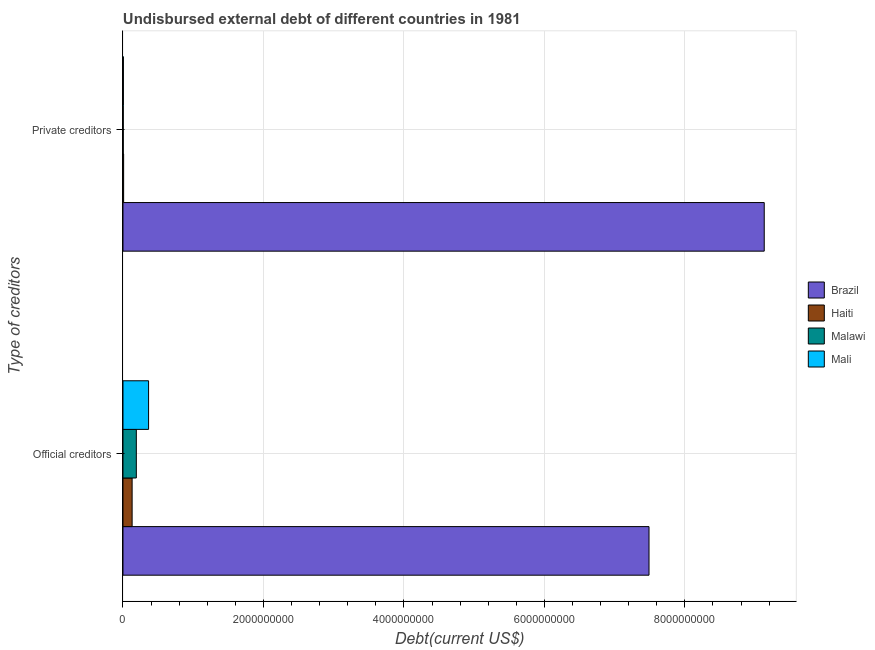How many groups of bars are there?
Provide a short and direct response. 2. Are the number of bars on each tick of the Y-axis equal?
Offer a very short reply. Yes. How many bars are there on the 1st tick from the bottom?
Provide a short and direct response. 4. What is the label of the 1st group of bars from the top?
Make the answer very short. Private creditors. What is the undisbursed external debt of official creditors in Haiti?
Keep it short and to the point. 1.30e+08. Across all countries, what is the maximum undisbursed external debt of official creditors?
Provide a short and direct response. 7.49e+09. Across all countries, what is the minimum undisbursed external debt of private creditors?
Offer a very short reply. 3.81e+06. In which country was the undisbursed external debt of private creditors minimum?
Provide a short and direct response. Malawi. What is the total undisbursed external debt of private creditors in the graph?
Offer a terse response. 9.15e+09. What is the difference between the undisbursed external debt of private creditors in Malawi and that in Haiti?
Give a very brief answer. -5.43e+06. What is the difference between the undisbursed external debt of private creditors in Malawi and the undisbursed external debt of official creditors in Brazil?
Keep it short and to the point. -7.49e+09. What is the average undisbursed external debt of private creditors per country?
Provide a succinct answer. 2.29e+09. What is the difference between the undisbursed external debt of official creditors and undisbursed external debt of private creditors in Brazil?
Offer a very short reply. -1.64e+09. What is the ratio of the undisbursed external debt of private creditors in Mali to that in Malawi?
Provide a succinct answer. 1.47. What does the 4th bar from the top in Official creditors represents?
Make the answer very short. Brazil. What does the 4th bar from the bottom in Official creditors represents?
Your answer should be compact. Mali. Are all the bars in the graph horizontal?
Keep it short and to the point. Yes. Does the graph contain any zero values?
Provide a succinct answer. No. Does the graph contain grids?
Your response must be concise. Yes. How many legend labels are there?
Offer a very short reply. 4. What is the title of the graph?
Give a very brief answer. Undisbursed external debt of different countries in 1981. Does "East Asia (all income levels)" appear as one of the legend labels in the graph?
Make the answer very short. No. What is the label or title of the X-axis?
Your answer should be compact. Debt(current US$). What is the label or title of the Y-axis?
Provide a succinct answer. Type of creditors. What is the Debt(current US$) in Brazil in Official creditors?
Give a very brief answer. 7.49e+09. What is the Debt(current US$) of Haiti in Official creditors?
Give a very brief answer. 1.30e+08. What is the Debt(current US$) in Malawi in Official creditors?
Your response must be concise. 1.90e+08. What is the Debt(current US$) in Mali in Official creditors?
Ensure brevity in your answer.  3.65e+08. What is the Debt(current US$) in Brazil in Private creditors?
Keep it short and to the point. 9.13e+09. What is the Debt(current US$) of Haiti in Private creditors?
Offer a very short reply. 9.24e+06. What is the Debt(current US$) of Malawi in Private creditors?
Make the answer very short. 3.81e+06. What is the Debt(current US$) of Mali in Private creditors?
Offer a very short reply. 5.60e+06. Across all Type of creditors, what is the maximum Debt(current US$) of Brazil?
Provide a succinct answer. 9.13e+09. Across all Type of creditors, what is the maximum Debt(current US$) in Haiti?
Keep it short and to the point. 1.30e+08. Across all Type of creditors, what is the maximum Debt(current US$) in Malawi?
Offer a terse response. 1.90e+08. Across all Type of creditors, what is the maximum Debt(current US$) of Mali?
Offer a very short reply. 3.65e+08. Across all Type of creditors, what is the minimum Debt(current US$) in Brazil?
Provide a succinct answer. 7.49e+09. Across all Type of creditors, what is the minimum Debt(current US$) of Haiti?
Offer a very short reply. 9.24e+06. Across all Type of creditors, what is the minimum Debt(current US$) of Malawi?
Your response must be concise. 3.81e+06. Across all Type of creditors, what is the minimum Debt(current US$) of Mali?
Your answer should be very brief. 5.60e+06. What is the total Debt(current US$) of Brazil in the graph?
Your answer should be compact. 1.66e+1. What is the total Debt(current US$) in Haiti in the graph?
Give a very brief answer. 1.39e+08. What is the total Debt(current US$) of Malawi in the graph?
Keep it short and to the point. 1.94e+08. What is the total Debt(current US$) of Mali in the graph?
Your answer should be very brief. 3.70e+08. What is the difference between the Debt(current US$) in Brazil in Official creditors and that in Private creditors?
Your answer should be very brief. -1.64e+09. What is the difference between the Debt(current US$) of Haiti in Official creditors and that in Private creditors?
Your answer should be compact. 1.21e+08. What is the difference between the Debt(current US$) in Malawi in Official creditors and that in Private creditors?
Your response must be concise. 1.86e+08. What is the difference between the Debt(current US$) of Mali in Official creditors and that in Private creditors?
Provide a succinct answer. 3.59e+08. What is the difference between the Debt(current US$) in Brazil in Official creditors and the Debt(current US$) in Haiti in Private creditors?
Keep it short and to the point. 7.48e+09. What is the difference between the Debt(current US$) of Brazil in Official creditors and the Debt(current US$) of Malawi in Private creditors?
Your response must be concise. 7.49e+09. What is the difference between the Debt(current US$) of Brazil in Official creditors and the Debt(current US$) of Mali in Private creditors?
Provide a succinct answer. 7.48e+09. What is the difference between the Debt(current US$) of Haiti in Official creditors and the Debt(current US$) of Malawi in Private creditors?
Offer a very short reply. 1.26e+08. What is the difference between the Debt(current US$) in Haiti in Official creditors and the Debt(current US$) in Mali in Private creditors?
Offer a very short reply. 1.25e+08. What is the difference between the Debt(current US$) of Malawi in Official creditors and the Debt(current US$) of Mali in Private creditors?
Keep it short and to the point. 1.84e+08. What is the average Debt(current US$) of Brazil per Type of creditors?
Make the answer very short. 8.31e+09. What is the average Debt(current US$) of Haiti per Type of creditors?
Offer a very short reply. 6.97e+07. What is the average Debt(current US$) of Malawi per Type of creditors?
Offer a terse response. 9.69e+07. What is the average Debt(current US$) of Mali per Type of creditors?
Provide a short and direct response. 1.85e+08. What is the difference between the Debt(current US$) of Brazil and Debt(current US$) of Haiti in Official creditors?
Provide a short and direct response. 7.36e+09. What is the difference between the Debt(current US$) of Brazil and Debt(current US$) of Malawi in Official creditors?
Your answer should be very brief. 7.30e+09. What is the difference between the Debt(current US$) in Brazil and Debt(current US$) in Mali in Official creditors?
Your answer should be compact. 7.13e+09. What is the difference between the Debt(current US$) in Haiti and Debt(current US$) in Malawi in Official creditors?
Ensure brevity in your answer.  -5.99e+07. What is the difference between the Debt(current US$) of Haiti and Debt(current US$) of Mali in Official creditors?
Ensure brevity in your answer.  -2.34e+08. What is the difference between the Debt(current US$) in Malawi and Debt(current US$) in Mali in Official creditors?
Keep it short and to the point. -1.75e+08. What is the difference between the Debt(current US$) of Brazil and Debt(current US$) of Haiti in Private creditors?
Provide a succinct answer. 9.12e+09. What is the difference between the Debt(current US$) in Brazil and Debt(current US$) in Malawi in Private creditors?
Ensure brevity in your answer.  9.13e+09. What is the difference between the Debt(current US$) of Brazil and Debt(current US$) of Mali in Private creditors?
Offer a very short reply. 9.12e+09. What is the difference between the Debt(current US$) of Haiti and Debt(current US$) of Malawi in Private creditors?
Keep it short and to the point. 5.43e+06. What is the difference between the Debt(current US$) in Haiti and Debt(current US$) in Mali in Private creditors?
Provide a succinct answer. 3.64e+06. What is the difference between the Debt(current US$) in Malawi and Debt(current US$) in Mali in Private creditors?
Your answer should be very brief. -1.79e+06. What is the ratio of the Debt(current US$) of Brazil in Official creditors to that in Private creditors?
Your answer should be compact. 0.82. What is the ratio of the Debt(current US$) in Haiti in Official creditors to that in Private creditors?
Make the answer very short. 14.08. What is the ratio of the Debt(current US$) in Malawi in Official creditors to that in Private creditors?
Keep it short and to the point. 49.85. What is the ratio of the Debt(current US$) of Mali in Official creditors to that in Private creditors?
Give a very brief answer. 65.1. What is the difference between the highest and the second highest Debt(current US$) of Brazil?
Provide a short and direct response. 1.64e+09. What is the difference between the highest and the second highest Debt(current US$) in Haiti?
Provide a succinct answer. 1.21e+08. What is the difference between the highest and the second highest Debt(current US$) of Malawi?
Give a very brief answer. 1.86e+08. What is the difference between the highest and the second highest Debt(current US$) in Mali?
Provide a short and direct response. 3.59e+08. What is the difference between the highest and the lowest Debt(current US$) in Brazil?
Your answer should be compact. 1.64e+09. What is the difference between the highest and the lowest Debt(current US$) of Haiti?
Make the answer very short. 1.21e+08. What is the difference between the highest and the lowest Debt(current US$) in Malawi?
Provide a succinct answer. 1.86e+08. What is the difference between the highest and the lowest Debt(current US$) of Mali?
Your response must be concise. 3.59e+08. 